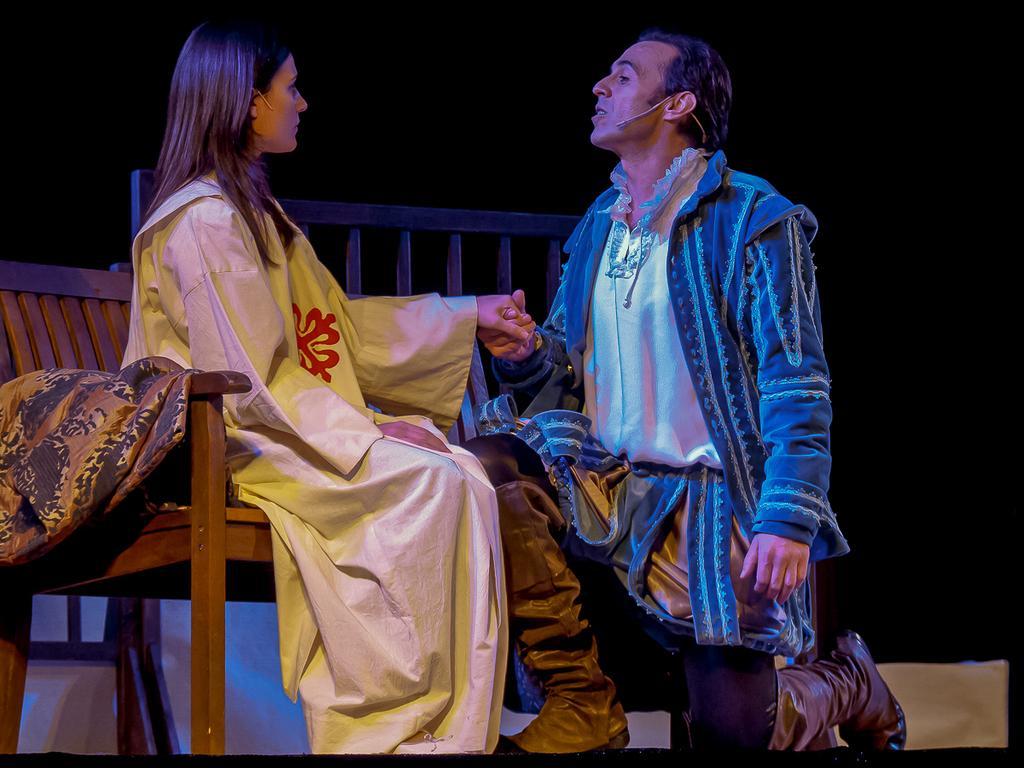Could you give a brief overview of what you see in this image? In this picture, there is a woman sitting on the bench towards the left and there is a man before her and he is in squatting position. He is wearing blue coat and black trousers. 